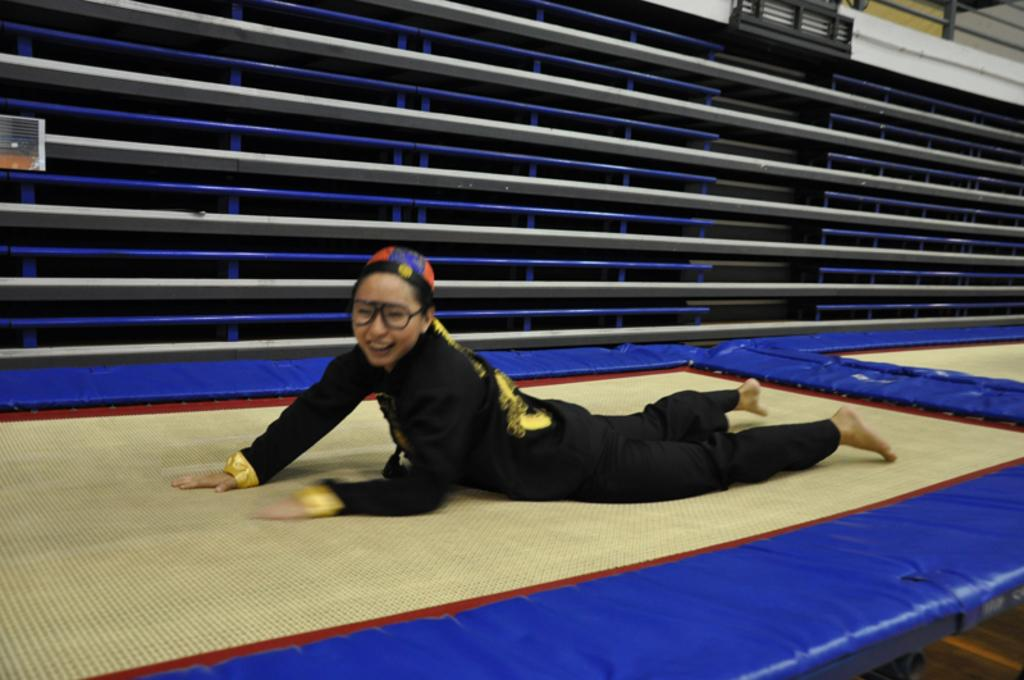What is the main subject of the image? The main subject of the image is a woman. What is the woman's position in the image? The woman is lying on a bed or mat. What is the woman's name in the image? The provided facts do not include the woman's name, so it cannot be determined from the image. What is the woman learning in the image? The provided facts do not mention any learning activity, so it cannot be determined from the image. 